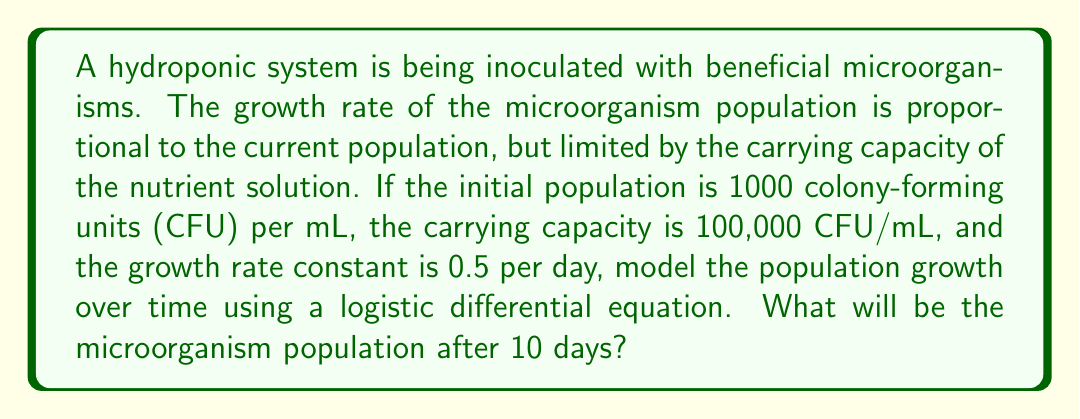What is the answer to this math problem? Let's approach this step-by-step:

1) The logistic growth model is given by the differential equation:

   $$\frac{dP}{dt} = rP(1 - \frac{P}{K})$$

   where $P$ is the population, $t$ is time, $r$ is the growth rate constant, and $K$ is the carrying capacity.

2) Given:
   - Initial population $P_0 = 1000$ CFU/mL
   - Carrying capacity $K = 100,000$ CFU/mL
   - Growth rate constant $r = 0.5$ per day

3) The solution to this differential equation is:

   $$P(t) = \frac{KP_0e^{rt}}{K + P_0(e^{rt} - 1)}$$

4) Substituting the given values:

   $$P(t) = \frac{100000 \cdot 1000 \cdot e^{0.5t}}{100000 + 1000(e^{0.5t} - 1)}$$

5) To find the population after 10 days, we substitute $t = 10$:

   $$P(10) = \frac{100000 \cdot 1000 \cdot e^{0.5 \cdot 10}}{100000 + 1000(e^{0.5 \cdot 10} - 1)}$$

6) Calculating:
   $$e^{0.5 \cdot 10} \approx 148.4131591$$

   $$P(10) = \frac{100000 \cdot 1000 \cdot 148.4131591}{100000 + 1000(148.4131591 - 1)}$$

   $$P(10) = \frac{14841315910}{247413.1591} \approx 59987.7$$

7) Rounding to the nearest whole number (as we're dealing with discrete units):

   $$P(10) \approx 59988 \text{ CFU/mL}$$
Answer: After 10 days, the microorganism population will be approximately 59,988 CFU/mL. 